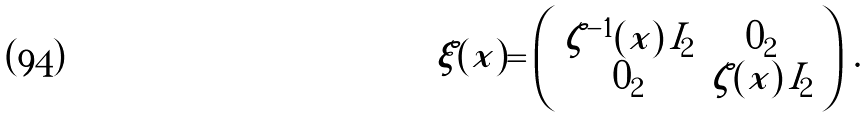Convert formula to latex. <formula><loc_0><loc_0><loc_500><loc_500>\xi ( x ) = \left ( \begin{array} { c c } \zeta ^ { - 1 } ( x ) \, I _ { 2 } & 0 _ { 2 } \\ 0 _ { 2 } & \zeta ( x ) \, I _ { 2 } \end{array} \right ) \, .</formula> 